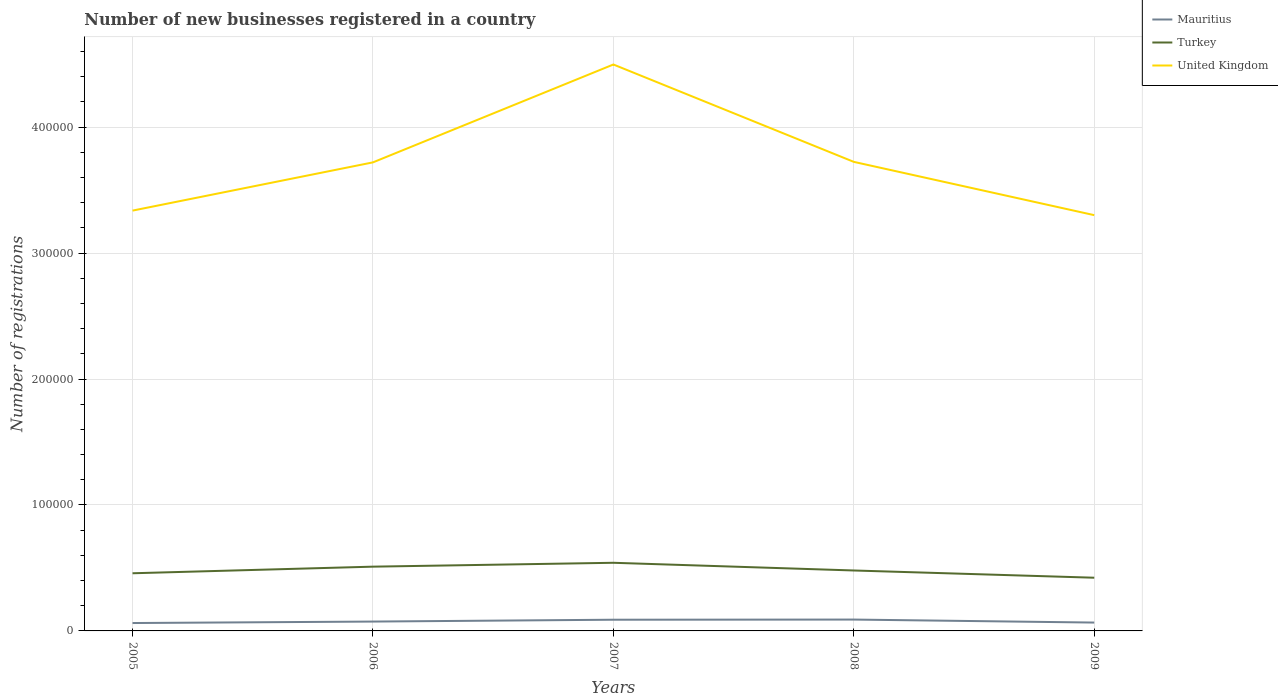How many different coloured lines are there?
Provide a short and direct response. 3. Is the number of lines equal to the number of legend labels?
Offer a terse response. Yes. Across all years, what is the maximum number of new businesses registered in Mauritius?
Your answer should be very brief. 6260. In which year was the number of new businesses registered in Mauritius maximum?
Provide a succinct answer. 2005. What is the total number of new businesses registered in United Kingdom in the graph?
Your answer should be compact. 7.73e+04. What is the difference between the highest and the second highest number of new businesses registered in United Kingdom?
Provide a short and direct response. 1.20e+05. Is the number of new businesses registered in Mauritius strictly greater than the number of new businesses registered in United Kingdom over the years?
Offer a terse response. Yes. How many lines are there?
Provide a short and direct response. 3. How many years are there in the graph?
Offer a very short reply. 5. What is the difference between two consecutive major ticks on the Y-axis?
Ensure brevity in your answer.  1.00e+05. Does the graph contain grids?
Offer a terse response. Yes. How are the legend labels stacked?
Offer a terse response. Vertical. What is the title of the graph?
Ensure brevity in your answer.  Number of new businesses registered in a country. What is the label or title of the X-axis?
Offer a very short reply. Years. What is the label or title of the Y-axis?
Your response must be concise. Number of registrations. What is the Number of registrations of Mauritius in 2005?
Ensure brevity in your answer.  6260. What is the Number of registrations in Turkey in 2005?
Your answer should be very brief. 4.58e+04. What is the Number of registrations of United Kingdom in 2005?
Provide a succinct answer. 3.34e+05. What is the Number of registrations of Mauritius in 2006?
Your answer should be very brief. 7435. What is the Number of registrations of Turkey in 2006?
Provide a succinct answer. 5.10e+04. What is the Number of registrations of United Kingdom in 2006?
Provide a succinct answer. 3.72e+05. What is the Number of registrations of Mauritius in 2007?
Your answer should be very brief. 8888. What is the Number of registrations of Turkey in 2007?
Ensure brevity in your answer.  5.41e+04. What is the Number of registrations in United Kingdom in 2007?
Make the answer very short. 4.50e+05. What is the Number of registrations of Mauritius in 2008?
Give a very brief answer. 9012. What is the Number of registrations of Turkey in 2008?
Provide a succinct answer. 4.80e+04. What is the Number of registrations in United Kingdom in 2008?
Your answer should be compact. 3.72e+05. What is the Number of registrations in Mauritius in 2009?
Give a very brief answer. 6631. What is the Number of registrations in Turkey in 2009?
Give a very brief answer. 4.22e+04. What is the Number of registrations of United Kingdom in 2009?
Keep it short and to the point. 3.30e+05. Across all years, what is the maximum Number of registrations in Mauritius?
Ensure brevity in your answer.  9012. Across all years, what is the maximum Number of registrations in Turkey?
Your answer should be very brief. 5.41e+04. Across all years, what is the maximum Number of registrations of United Kingdom?
Make the answer very short. 4.50e+05. Across all years, what is the minimum Number of registrations of Mauritius?
Your response must be concise. 6260. Across all years, what is the minimum Number of registrations of Turkey?
Give a very brief answer. 4.22e+04. Across all years, what is the minimum Number of registrations of United Kingdom?
Offer a very short reply. 3.30e+05. What is the total Number of registrations of Mauritius in the graph?
Your response must be concise. 3.82e+04. What is the total Number of registrations of Turkey in the graph?
Your response must be concise. 2.41e+05. What is the total Number of registrations in United Kingdom in the graph?
Make the answer very short. 1.86e+06. What is the difference between the Number of registrations in Mauritius in 2005 and that in 2006?
Provide a succinct answer. -1175. What is the difference between the Number of registrations in Turkey in 2005 and that in 2006?
Keep it short and to the point. -5252. What is the difference between the Number of registrations of United Kingdom in 2005 and that in 2006?
Provide a short and direct response. -3.83e+04. What is the difference between the Number of registrations in Mauritius in 2005 and that in 2007?
Give a very brief answer. -2628. What is the difference between the Number of registrations of Turkey in 2005 and that in 2007?
Provide a short and direct response. -8326. What is the difference between the Number of registrations in United Kingdom in 2005 and that in 2007?
Provide a succinct answer. -1.16e+05. What is the difference between the Number of registrations of Mauritius in 2005 and that in 2008?
Keep it short and to the point. -2752. What is the difference between the Number of registrations in Turkey in 2005 and that in 2008?
Make the answer very short. -2208. What is the difference between the Number of registrations in United Kingdom in 2005 and that in 2008?
Keep it short and to the point. -3.87e+04. What is the difference between the Number of registrations in Mauritius in 2005 and that in 2009?
Provide a succinct answer. -371. What is the difference between the Number of registrations of Turkey in 2005 and that in 2009?
Your answer should be very brief. 3538. What is the difference between the Number of registrations of United Kingdom in 2005 and that in 2009?
Ensure brevity in your answer.  3600. What is the difference between the Number of registrations in Mauritius in 2006 and that in 2007?
Provide a succinct answer. -1453. What is the difference between the Number of registrations in Turkey in 2006 and that in 2007?
Your answer should be compact. -3074. What is the difference between the Number of registrations in United Kingdom in 2006 and that in 2007?
Your response must be concise. -7.77e+04. What is the difference between the Number of registrations in Mauritius in 2006 and that in 2008?
Offer a terse response. -1577. What is the difference between the Number of registrations in Turkey in 2006 and that in 2008?
Offer a terse response. 3044. What is the difference between the Number of registrations in United Kingdom in 2006 and that in 2008?
Your response must be concise. -400. What is the difference between the Number of registrations in Mauritius in 2006 and that in 2009?
Keep it short and to the point. 804. What is the difference between the Number of registrations of Turkey in 2006 and that in 2009?
Make the answer very short. 8790. What is the difference between the Number of registrations in United Kingdom in 2006 and that in 2009?
Offer a terse response. 4.19e+04. What is the difference between the Number of registrations in Mauritius in 2007 and that in 2008?
Your answer should be very brief. -124. What is the difference between the Number of registrations of Turkey in 2007 and that in 2008?
Your answer should be very brief. 6118. What is the difference between the Number of registrations in United Kingdom in 2007 and that in 2008?
Provide a succinct answer. 7.73e+04. What is the difference between the Number of registrations of Mauritius in 2007 and that in 2009?
Keep it short and to the point. 2257. What is the difference between the Number of registrations of Turkey in 2007 and that in 2009?
Your response must be concise. 1.19e+04. What is the difference between the Number of registrations of United Kingdom in 2007 and that in 2009?
Provide a succinct answer. 1.20e+05. What is the difference between the Number of registrations in Mauritius in 2008 and that in 2009?
Offer a very short reply. 2381. What is the difference between the Number of registrations in Turkey in 2008 and that in 2009?
Your answer should be compact. 5746. What is the difference between the Number of registrations in United Kingdom in 2008 and that in 2009?
Offer a terse response. 4.23e+04. What is the difference between the Number of registrations of Mauritius in 2005 and the Number of registrations of Turkey in 2006?
Offer a terse response. -4.48e+04. What is the difference between the Number of registrations of Mauritius in 2005 and the Number of registrations of United Kingdom in 2006?
Offer a very short reply. -3.66e+05. What is the difference between the Number of registrations of Turkey in 2005 and the Number of registrations of United Kingdom in 2006?
Provide a short and direct response. -3.26e+05. What is the difference between the Number of registrations in Mauritius in 2005 and the Number of registrations in Turkey in 2007?
Give a very brief answer. -4.78e+04. What is the difference between the Number of registrations of Mauritius in 2005 and the Number of registrations of United Kingdom in 2007?
Your response must be concise. -4.43e+05. What is the difference between the Number of registrations of Turkey in 2005 and the Number of registrations of United Kingdom in 2007?
Your answer should be very brief. -4.04e+05. What is the difference between the Number of registrations in Mauritius in 2005 and the Number of registrations in Turkey in 2008?
Make the answer very short. -4.17e+04. What is the difference between the Number of registrations in Mauritius in 2005 and the Number of registrations in United Kingdom in 2008?
Offer a very short reply. -3.66e+05. What is the difference between the Number of registrations of Turkey in 2005 and the Number of registrations of United Kingdom in 2008?
Provide a succinct answer. -3.27e+05. What is the difference between the Number of registrations in Mauritius in 2005 and the Number of registrations in Turkey in 2009?
Offer a terse response. -3.60e+04. What is the difference between the Number of registrations in Mauritius in 2005 and the Number of registrations in United Kingdom in 2009?
Make the answer very short. -3.24e+05. What is the difference between the Number of registrations in Turkey in 2005 and the Number of registrations in United Kingdom in 2009?
Offer a very short reply. -2.84e+05. What is the difference between the Number of registrations in Mauritius in 2006 and the Number of registrations in Turkey in 2007?
Keep it short and to the point. -4.67e+04. What is the difference between the Number of registrations of Mauritius in 2006 and the Number of registrations of United Kingdom in 2007?
Offer a very short reply. -4.42e+05. What is the difference between the Number of registrations of Turkey in 2006 and the Number of registrations of United Kingdom in 2007?
Keep it short and to the point. -3.99e+05. What is the difference between the Number of registrations of Mauritius in 2006 and the Number of registrations of Turkey in 2008?
Offer a very short reply. -4.05e+04. What is the difference between the Number of registrations in Mauritius in 2006 and the Number of registrations in United Kingdom in 2008?
Your response must be concise. -3.65e+05. What is the difference between the Number of registrations in Turkey in 2006 and the Number of registrations in United Kingdom in 2008?
Provide a short and direct response. -3.21e+05. What is the difference between the Number of registrations in Mauritius in 2006 and the Number of registrations in Turkey in 2009?
Provide a short and direct response. -3.48e+04. What is the difference between the Number of registrations in Mauritius in 2006 and the Number of registrations in United Kingdom in 2009?
Ensure brevity in your answer.  -3.23e+05. What is the difference between the Number of registrations in Turkey in 2006 and the Number of registrations in United Kingdom in 2009?
Provide a succinct answer. -2.79e+05. What is the difference between the Number of registrations in Mauritius in 2007 and the Number of registrations in Turkey in 2008?
Your response must be concise. -3.91e+04. What is the difference between the Number of registrations of Mauritius in 2007 and the Number of registrations of United Kingdom in 2008?
Provide a succinct answer. -3.64e+05. What is the difference between the Number of registrations in Turkey in 2007 and the Number of registrations in United Kingdom in 2008?
Offer a very short reply. -3.18e+05. What is the difference between the Number of registrations in Mauritius in 2007 and the Number of registrations in Turkey in 2009?
Keep it short and to the point. -3.33e+04. What is the difference between the Number of registrations of Mauritius in 2007 and the Number of registrations of United Kingdom in 2009?
Your answer should be very brief. -3.21e+05. What is the difference between the Number of registrations in Turkey in 2007 and the Number of registrations in United Kingdom in 2009?
Offer a terse response. -2.76e+05. What is the difference between the Number of registrations of Mauritius in 2008 and the Number of registrations of Turkey in 2009?
Provide a succinct answer. -3.32e+04. What is the difference between the Number of registrations of Mauritius in 2008 and the Number of registrations of United Kingdom in 2009?
Your answer should be compact. -3.21e+05. What is the difference between the Number of registrations of Turkey in 2008 and the Number of registrations of United Kingdom in 2009?
Provide a short and direct response. -2.82e+05. What is the average Number of registrations in Mauritius per year?
Keep it short and to the point. 7645.2. What is the average Number of registrations of Turkey per year?
Your response must be concise. 4.82e+04. What is the average Number of registrations in United Kingdom per year?
Your answer should be very brief. 3.72e+05. In the year 2005, what is the difference between the Number of registrations in Mauritius and Number of registrations in Turkey?
Provide a short and direct response. -3.95e+04. In the year 2005, what is the difference between the Number of registrations of Mauritius and Number of registrations of United Kingdom?
Your answer should be compact. -3.27e+05. In the year 2005, what is the difference between the Number of registrations of Turkey and Number of registrations of United Kingdom?
Offer a very short reply. -2.88e+05. In the year 2006, what is the difference between the Number of registrations in Mauritius and Number of registrations in Turkey?
Your answer should be compact. -4.36e+04. In the year 2006, what is the difference between the Number of registrations in Mauritius and Number of registrations in United Kingdom?
Offer a terse response. -3.65e+05. In the year 2006, what is the difference between the Number of registrations in Turkey and Number of registrations in United Kingdom?
Ensure brevity in your answer.  -3.21e+05. In the year 2007, what is the difference between the Number of registrations of Mauritius and Number of registrations of Turkey?
Ensure brevity in your answer.  -4.52e+04. In the year 2007, what is the difference between the Number of registrations in Mauritius and Number of registrations in United Kingdom?
Make the answer very short. -4.41e+05. In the year 2007, what is the difference between the Number of registrations of Turkey and Number of registrations of United Kingdom?
Your response must be concise. -3.96e+05. In the year 2008, what is the difference between the Number of registrations of Mauritius and Number of registrations of Turkey?
Provide a short and direct response. -3.90e+04. In the year 2008, what is the difference between the Number of registrations in Mauritius and Number of registrations in United Kingdom?
Keep it short and to the point. -3.63e+05. In the year 2008, what is the difference between the Number of registrations of Turkey and Number of registrations of United Kingdom?
Give a very brief answer. -3.24e+05. In the year 2009, what is the difference between the Number of registrations of Mauritius and Number of registrations of Turkey?
Your response must be concise. -3.56e+04. In the year 2009, what is the difference between the Number of registrations in Mauritius and Number of registrations in United Kingdom?
Your response must be concise. -3.23e+05. In the year 2009, what is the difference between the Number of registrations of Turkey and Number of registrations of United Kingdom?
Provide a short and direct response. -2.88e+05. What is the ratio of the Number of registrations in Mauritius in 2005 to that in 2006?
Provide a succinct answer. 0.84. What is the ratio of the Number of registrations in Turkey in 2005 to that in 2006?
Your response must be concise. 0.9. What is the ratio of the Number of registrations of United Kingdom in 2005 to that in 2006?
Provide a succinct answer. 0.9. What is the ratio of the Number of registrations in Mauritius in 2005 to that in 2007?
Your response must be concise. 0.7. What is the ratio of the Number of registrations of Turkey in 2005 to that in 2007?
Give a very brief answer. 0.85. What is the ratio of the Number of registrations in United Kingdom in 2005 to that in 2007?
Provide a short and direct response. 0.74. What is the ratio of the Number of registrations in Mauritius in 2005 to that in 2008?
Ensure brevity in your answer.  0.69. What is the ratio of the Number of registrations in Turkey in 2005 to that in 2008?
Make the answer very short. 0.95. What is the ratio of the Number of registrations in United Kingdom in 2005 to that in 2008?
Keep it short and to the point. 0.9. What is the ratio of the Number of registrations in Mauritius in 2005 to that in 2009?
Your answer should be very brief. 0.94. What is the ratio of the Number of registrations in Turkey in 2005 to that in 2009?
Your response must be concise. 1.08. What is the ratio of the Number of registrations in United Kingdom in 2005 to that in 2009?
Provide a short and direct response. 1.01. What is the ratio of the Number of registrations in Mauritius in 2006 to that in 2007?
Give a very brief answer. 0.84. What is the ratio of the Number of registrations in Turkey in 2006 to that in 2007?
Keep it short and to the point. 0.94. What is the ratio of the Number of registrations of United Kingdom in 2006 to that in 2007?
Offer a very short reply. 0.83. What is the ratio of the Number of registrations in Mauritius in 2006 to that in 2008?
Provide a succinct answer. 0.82. What is the ratio of the Number of registrations in Turkey in 2006 to that in 2008?
Your answer should be compact. 1.06. What is the ratio of the Number of registrations in United Kingdom in 2006 to that in 2008?
Your response must be concise. 1. What is the ratio of the Number of registrations of Mauritius in 2006 to that in 2009?
Make the answer very short. 1.12. What is the ratio of the Number of registrations in Turkey in 2006 to that in 2009?
Your answer should be compact. 1.21. What is the ratio of the Number of registrations in United Kingdom in 2006 to that in 2009?
Provide a short and direct response. 1.13. What is the ratio of the Number of registrations in Mauritius in 2007 to that in 2008?
Give a very brief answer. 0.99. What is the ratio of the Number of registrations of Turkey in 2007 to that in 2008?
Your answer should be very brief. 1.13. What is the ratio of the Number of registrations of United Kingdom in 2007 to that in 2008?
Keep it short and to the point. 1.21. What is the ratio of the Number of registrations in Mauritius in 2007 to that in 2009?
Your answer should be compact. 1.34. What is the ratio of the Number of registrations of Turkey in 2007 to that in 2009?
Your answer should be very brief. 1.28. What is the ratio of the Number of registrations in United Kingdom in 2007 to that in 2009?
Your answer should be very brief. 1.36. What is the ratio of the Number of registrations of Mauritius in 2008 to that in 2009?
Provide a short and direct response. 1.36. What is the ratio of the Number of registrations of Turkey in 2008 to that in 2009?
Make the answer very short. 1.14. What is the ratio of the Number of registrations in United Kingdom in 2008 to that in 2009?
Your answer should be very brief. 1.13. What is the difference between the highest and the second highest Number of registrations of Mauritius?
Make the answer very short. 124. What is the difference between the highest and the second highest Number of registrations in Turkey?
Give a very brief answer. 3074. What is the difference between the highest and the second highest Number of registrations in United Kingdom?
Ensure brevity in your answer.  7.73e+04. What is the difference between the highest and the lowest Number of registrations of Mauritius?
Keep it short and to the point. 2752. What is the difference between the highest and the lowest Number of registrations of Turkey?
Keep it short and to the point. 1.19e+04. What is the difference between the highest and the lowest Number of registrations of United Kingdom?
Provide a succinct answer. 1.20e+05. 